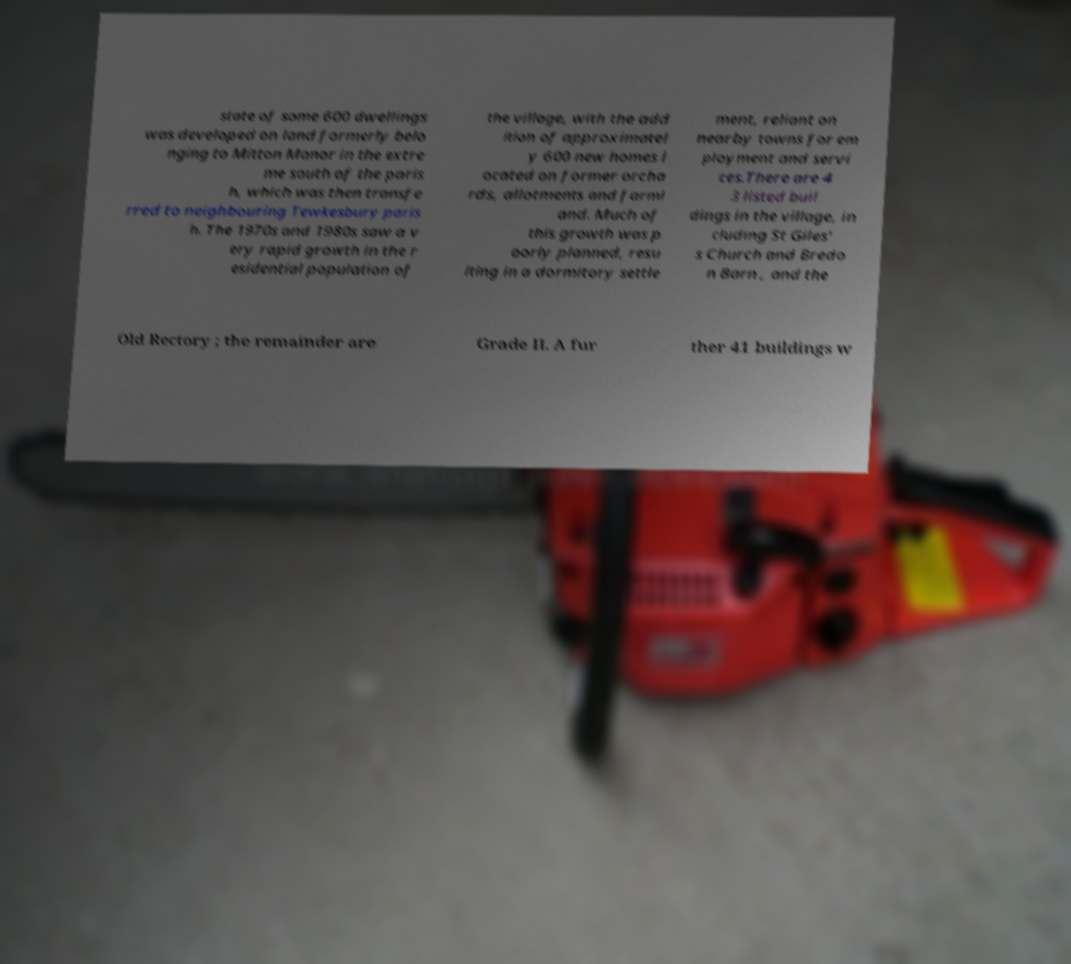For documentation purposes, I need the text within this image transcribed. Could you provide that? state of some 600 dwellings was developed on land formerly belo nging to Mitton Manor in the extre me south of the paris h, which was then transfe rred to neighbouring Tewkesbury paris h. The 1970s and 1980s saw a v ery rapid growth in the r esidential population of the village, with the add ition of approximatel y 600 new homes l ocated on former orcha rds, allotments and farml and. Much of this growth was p oorly planned, resu lting in a dormitory settle ment, reliant on nearby towns for em ployment and servi ces.There are 4 3 listed buil dings in the village, in cluding St Giles' s Church and Bredo n Barn , and the Old Rectory ; the remainder are Grade II. A fur ther 41 buildings w 